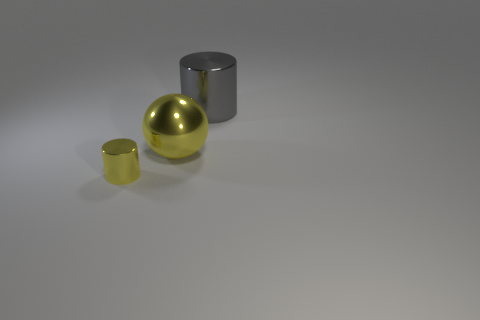Add 3 tiny gray rubber cylinders. How many objects exist? 6 Subtract all spheres. How many objects are left? 2 Add 3 small metallic cylinders. How many small metallic cylinders are left? 4 Add 1 large spheres. How many large spheres exist? 2 Subtract 0 gray cubes. How many objects are left? 3 Subtract all yellow things. Subtract all tiny metal cylinders. How many objects are left? 0 